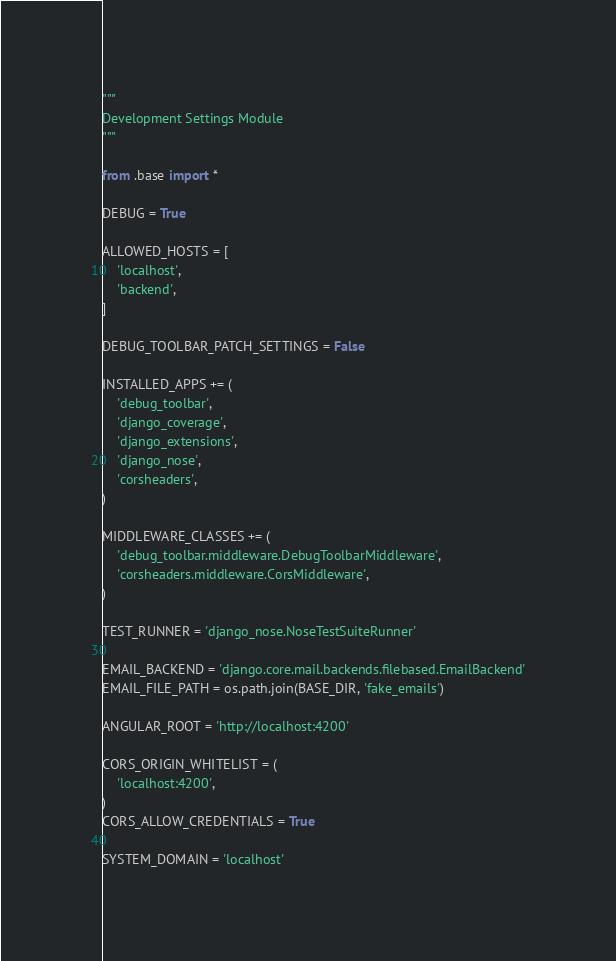<code> <loc_0><loc_0><loc_500><loc_500><_Python_>"""
Development Settings Module
"""

from .base import *

DEBUG = True

ALLOWED_HOSTS = [
    'localhost',
    'backend',
]

DEBUG_TOOLBAR_PATCH_SETTINGS = False

INSTALLED_APPS += (
    'debug_toolbar',
    'django_coverage',
    'django_extensions',
    'django_nose',
    'corsheaders',
)

MIDDLEWARE_CLASSES += (
    'debug_toolbar.middleware.DebugToolbarMiddleware',
    'corsheaders.middleware.CorsMiddleware',
)

TEST_RUNNER = 'django_nose.NoseTestSuiteRunner'

EMAIL_BACKEND = 'django.core.mail.backends.filebased.EmailBackend'
EMAIL_FILE_PATH = os.path.join(BASE_DIR, 'fake_emails')

ANGULAR_ROOT = 'http://localhost:4200'

CORS_ORIGIN_WHITELIST = (
    'localhost:4200',
)
CORS_ALLOW_CREDENTIALS = True

SYSTEM_DOMAIN = 'localhost'
</code> 